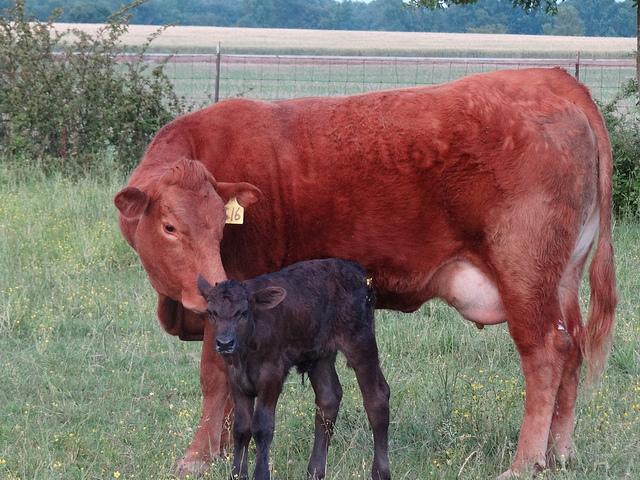What number is the tag?
Be succinct. 16. What color is the younger cow?
Give a very brief answer. Black. Is the cow the calf's mother?
Answer briefly. Yes. Is the cow wearing an earring?
Keep it brief. Yes. What is the number on the cow's ear?
Keep it brief. 16. What color is the calf?
Give a very brief answer. Black. 